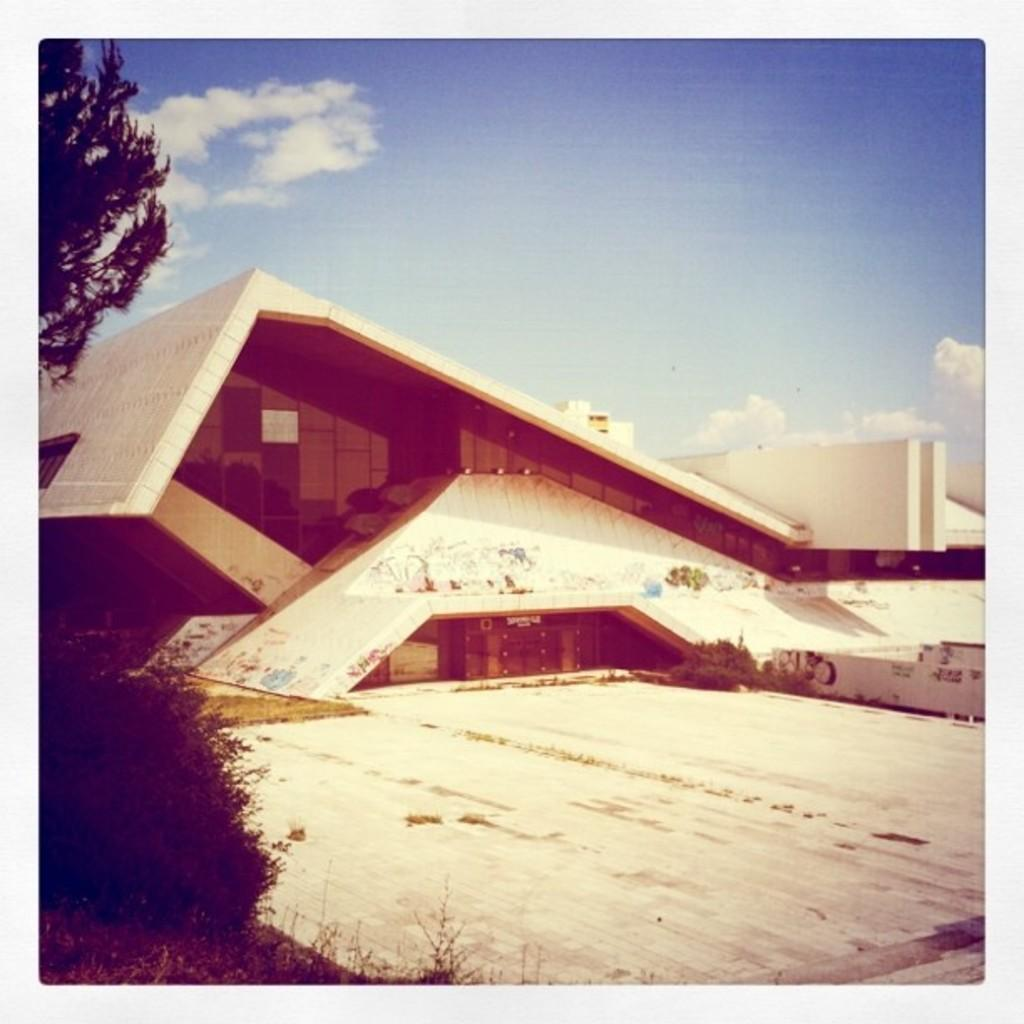What structure is present in the image? There is a building in the image. What can be seen on the left side of the image? There is a tree and a plant on the left side of the image. What is visible in the background of the image? The sky is visible in the background of the image. What can be observed in the sky? There are clouds in the sky. What type of oil is being used for driving in the image? There is no reference to driving or oil in the image; it features a building, a tree, a plant, and a sky with clouds. 